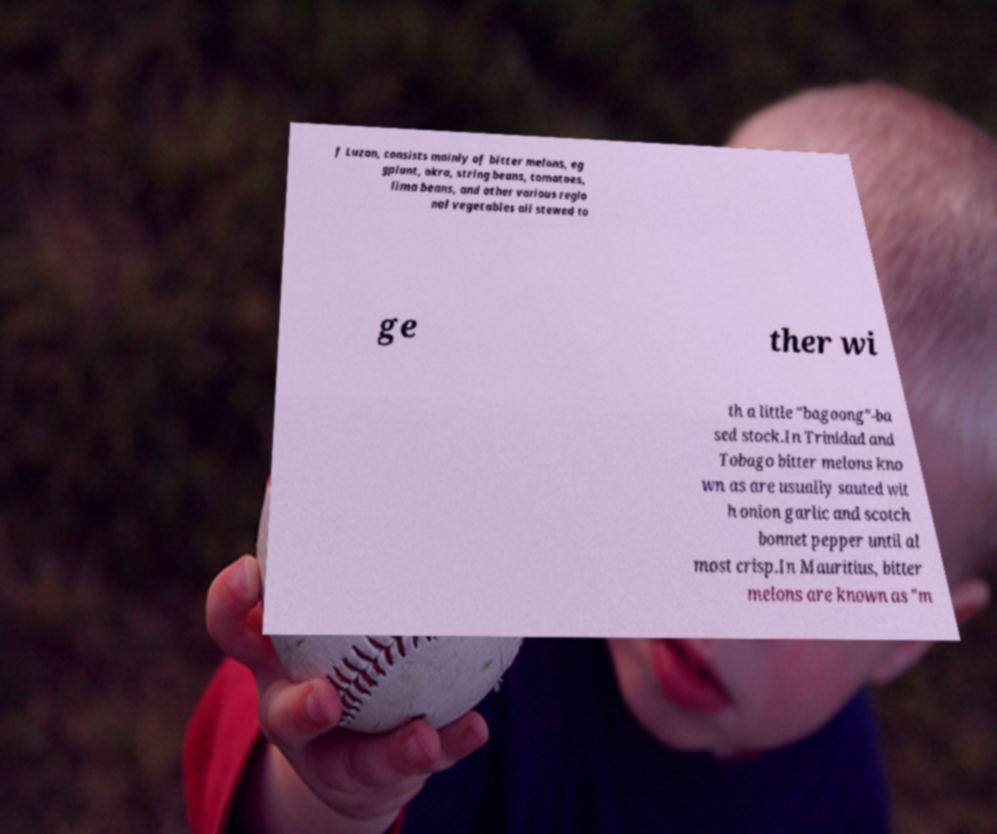What messages or text are displayed in this image? I need them in a readable, typed format. f Luzon, consists mainly of bitter melons, eg gplant, okra, string beans, tomatoes, lima beans, and other various regio nal vegetables all stewed to ge ther wi th a little "bagoong"-ba sed stock.In Trinidad and Tobago bitter melons kno wn as are usually sauted wit h onion garlic and scotch bonnet pepper until al most crisp.In Mauritius, bitter melons are known as "m 